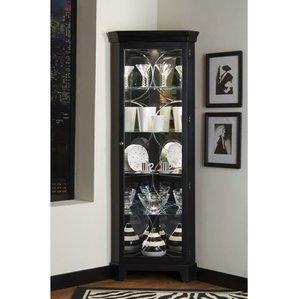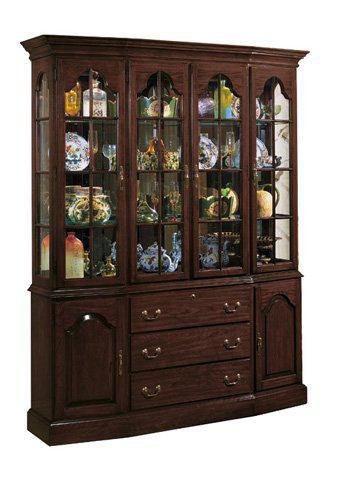The first image is the image on the left, the second image is the image on the right. Assess this claim about the two images: "One of the cabinets is empty.". Correct or not? Answer yes or no. No. 